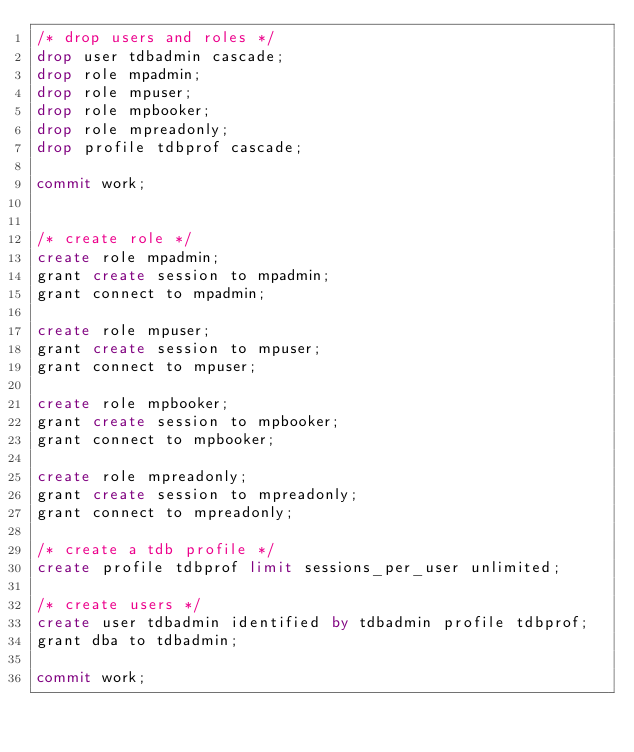<code> <loc_0><loc_0><loc_500><loc_500><_SQL_>/* drop users and roles */
drop user tdbadmin cascade;
drop role mpadmin;
drop role mpuser;
drop role mpbooker;
drop role mpreadonly;
drop profile tdbprof cascade;

commit work;


/* create role */ 
create role mpadmin; 
grant create session to mpadmin; 
grant connect to mpadmin; 

create role mpuser; 
grant create session to mpuser; 
grant connect to mpuser; 

create role mpbooker; 
grant create session to mpbooker; 
grant connect to mpbooker; 

create role mpreadonly; 
grant create session to mpreadonly; 
grant connect to mpreadonly;  

/* create a tdb profile */ 
create profile tdbprof limit sessions_per_user unlimited;  

/* create users */ 
create user tdbadmin identified by tdbadmin profile tdbprof;
grant dba to tdbadmin;

commit work;</code> 